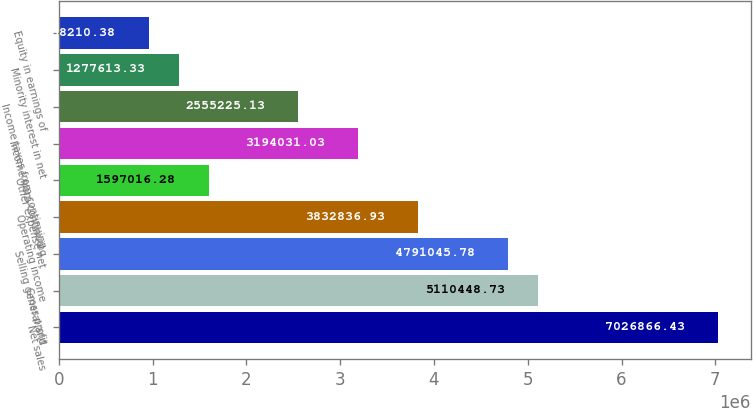Convert chart to OTSL. <chart><loc_0><loc_0><loc_500><loc_500><bar_chart><fcel>Net sales<fcel>Gross profit<fcel>Selling general and<fcel>Operating income<fcel>Other expense net<fcel>Income from continuing<fcel>Income taxes from continuing<fcel>Minority interest in net<fcel>Equity in earnings of<nl><fcel>7.02687e+06<fcel>5.11045e+06<fcel>4.79105e+06<fcel>3.83284e+06<fcel>1.59702e+06<fcel>3.19403e+06<fcel>2.55523e+06<fcel>1.27761e+06<fcel>958210<nl></chart> 